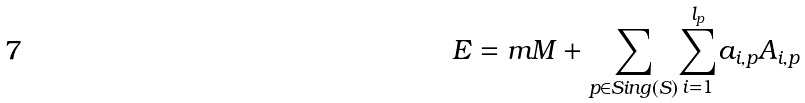<formula> <loc_0><loc_0><loc_500><loc_500>E = m M + \underset { p \in S i n g ( S ) } { \sum } \overset { l _ { p } } { \underset { i = 1 } { \sum } } a _ { i , p } A _ { i , p }</formula> 